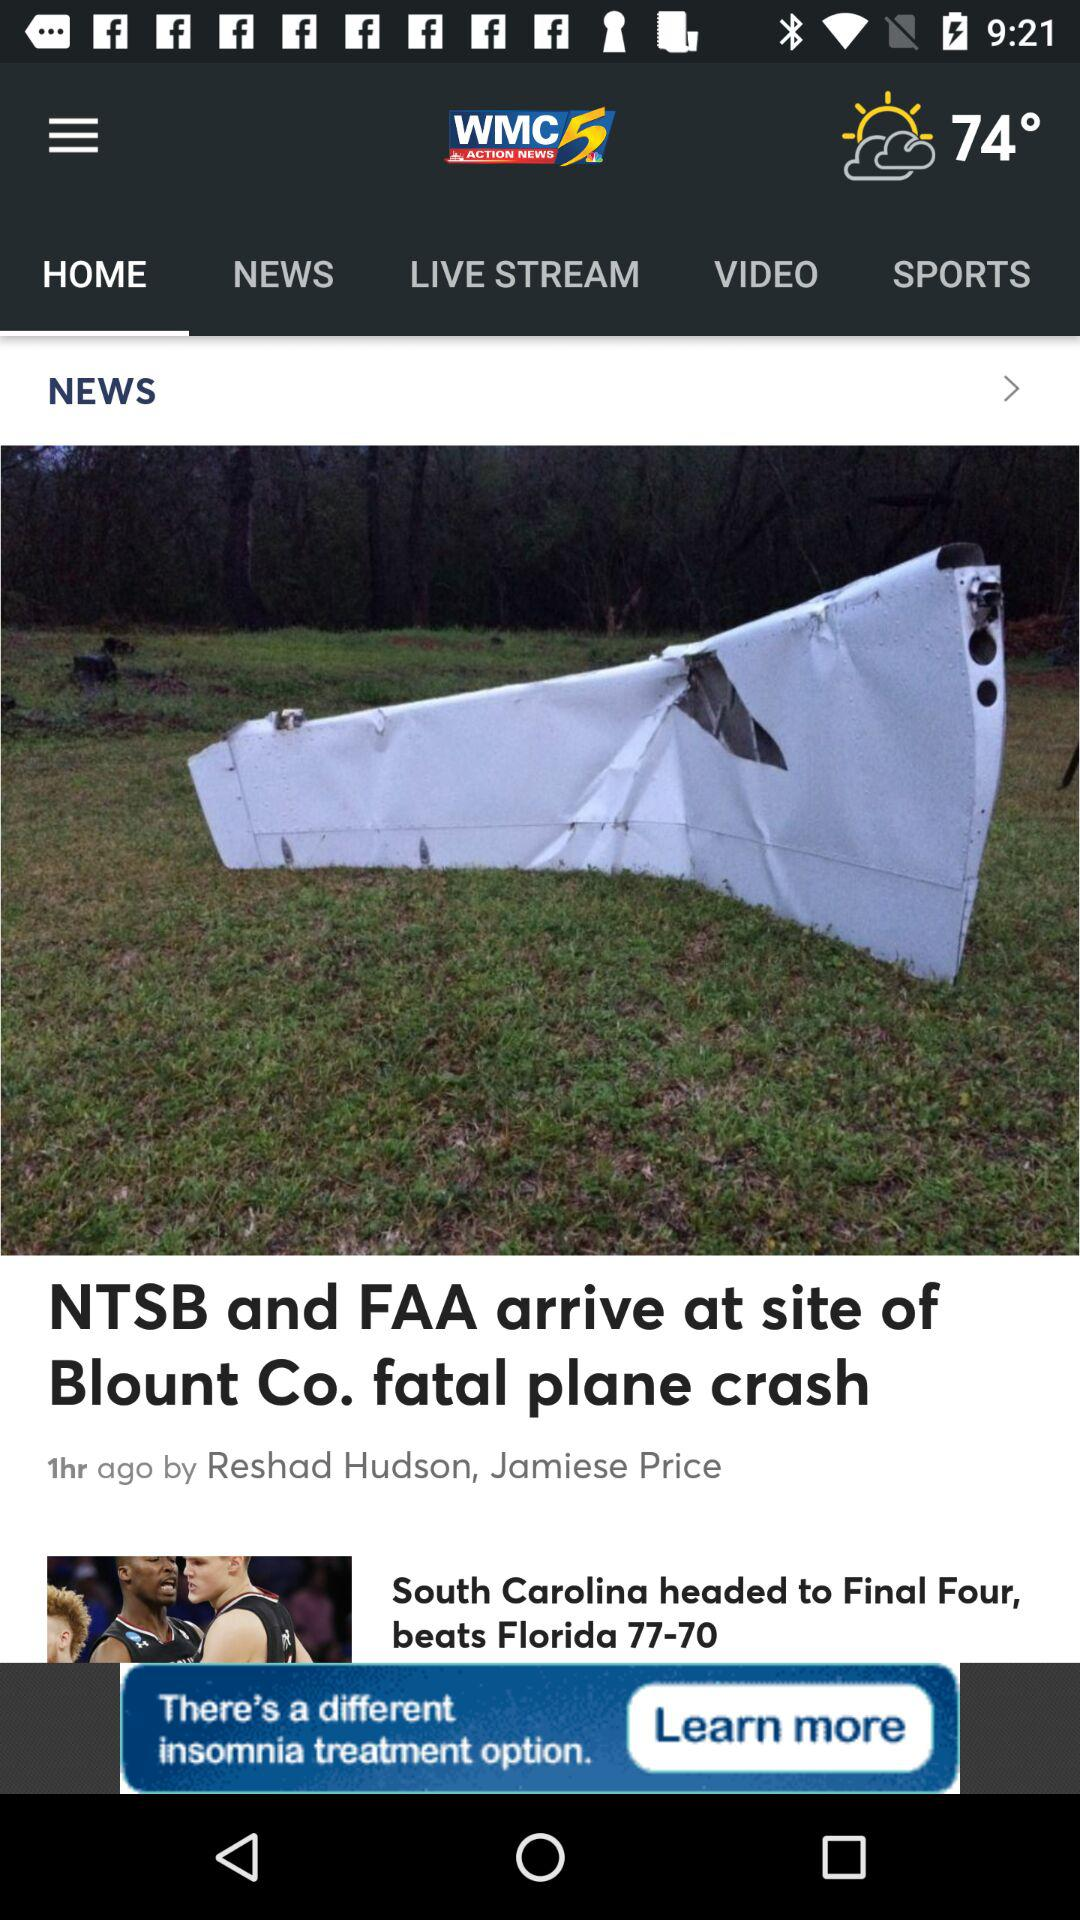Who is the reporter? The reporters are Reshad Hudson and Jamiese Price. 